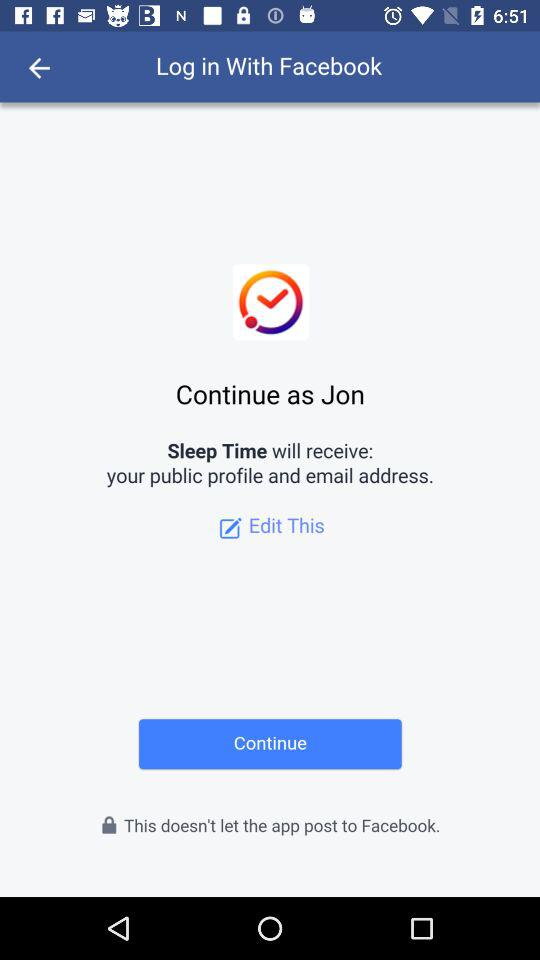What is the login name? The login name is Jon. 